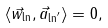<formula> <loc_0><loc_0><loc_500><loc_500>\langle \vec { w } _ { \ln } , \vec { a } _ { \ln ^ { \prime } } \rangle = 0 ,</formula> 